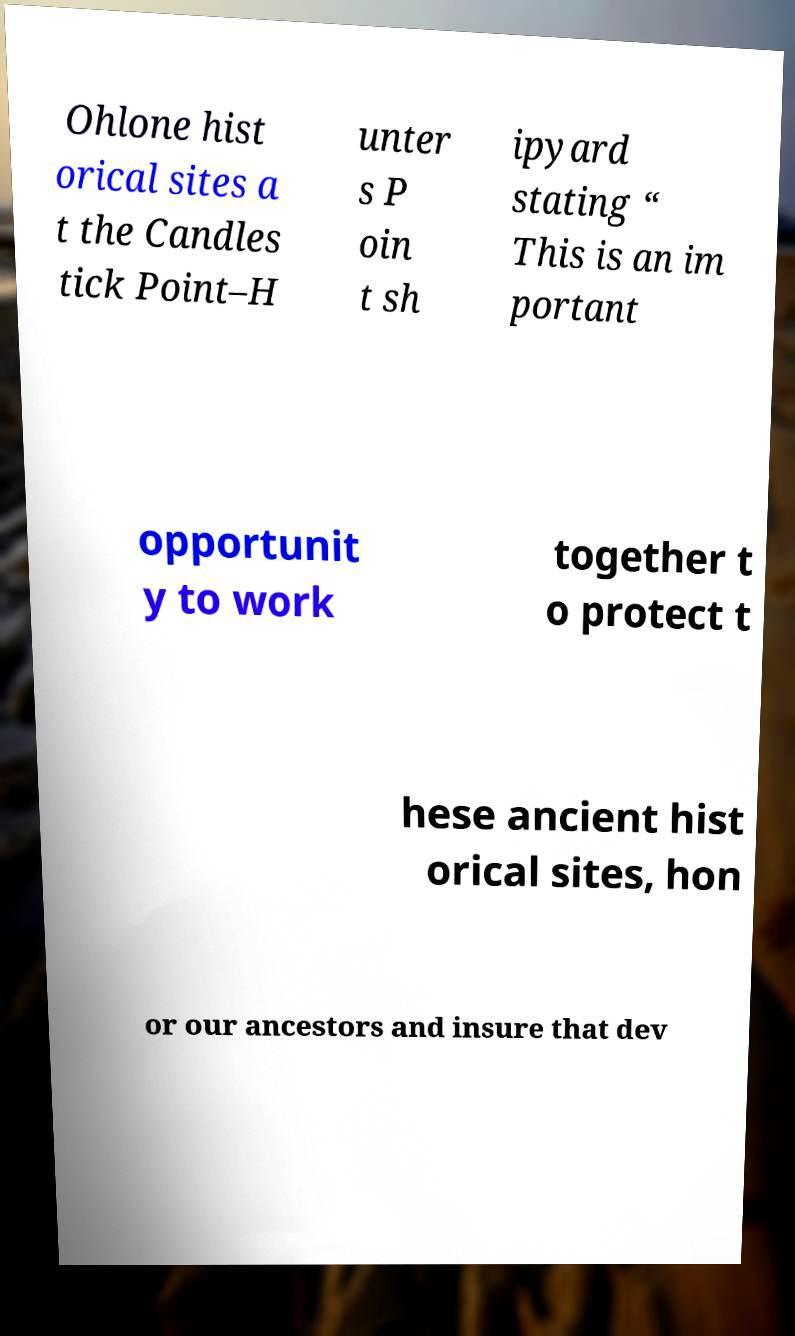I need the written content from this picture converted into text. Can you do that? Ohlone hist orical sites a t the Candles tick Point–H unter s P oin t sh ipyard stating “ This is an im portant opportunit y to work together t o protect t hese ancient hist orical sites, hon or our ancestors and insure that dev 